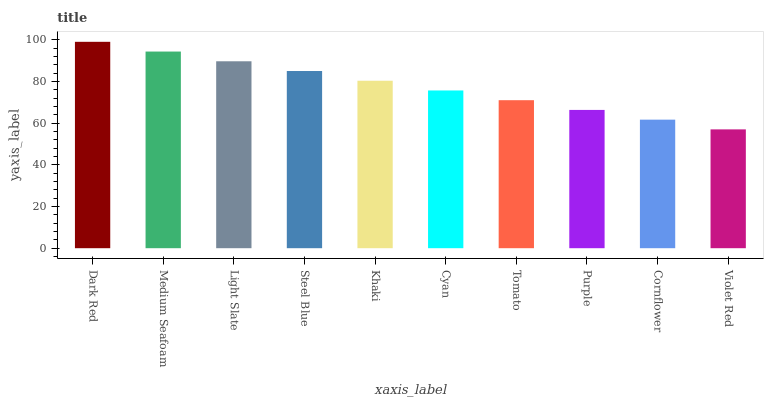Is Violet Red the minimum?
Answer yes or no. Yes. Is Dark Red the maximum?
Answer yes or no. Yes. Is Medium Seafoam the minimum?
Answer yes or no. No. Is Medium Seafoam the maximum?
Answer yes or no. No. Is Dark Red greater than Medium Seafoam?
Answer yes or no. Yes. Is Medium Seafoam less than Dark Red?
Answer yes or no. Yes. Is Medium Seafoam greater than Dark Red?
Answer yes or no. No. Is Dark Red less than Medium Seafoam?
Answer yes or no. No. Is Khaki the high median?
Answer yes or no. Yes. Is Cyan the low median?
Answer yes or no. Yes. Is Light Slate the high median?
Answer yes or no. No. Is Violet Red the low median?
Answer yes or no. No. 